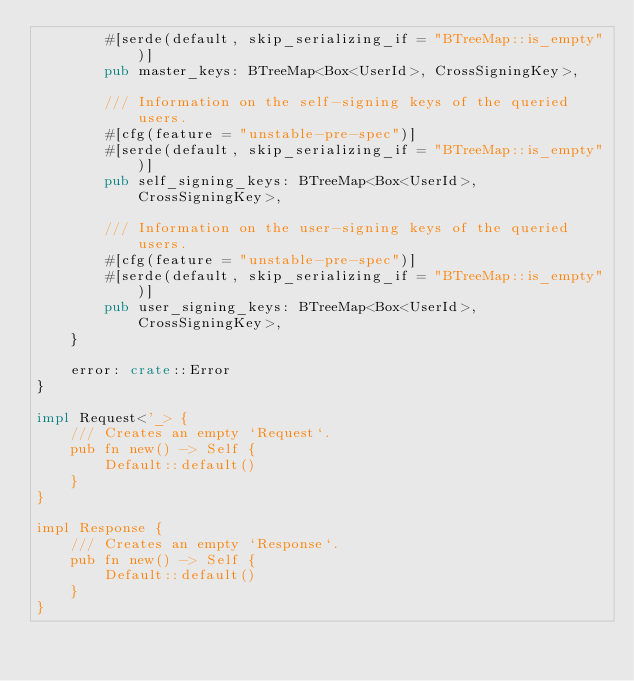<code> <loc_0><loc_0><loc_500><loc_500><_Rust_>        #[serde(default, skip_serializing_if = "BTreeMap::is_empty")]
        pub master_keys: BTreeMap<Box<UserId>, CrossSigningKey>,

        /// Information on the self-signing keys of the queried users.
        #[cfg(feature = "unstable-pre-spec")]
        #[serde(default, skip_serializing_if = "BTreeMap::is_empty")]
        pub self_signing_keys: BTreeMap<Box<UserId>, CrossSigningKey>,

        /// Information on the user-signing keys of the queried users.
        #[cfg(feature = "unstable-pre-spec")]
        #[serde(default, skip_serializing_if = "BTreeMap::is_empty")]
        pub user_signing_keys: BTreeMap<Box<UserId>, CrossSigningKey>,
    }

    error: crate::Error
}

impl Request<'_> {
    /// Creates an empty `Request`.
    pub fn new() -> Self {
        Default::default()
    }
}

impl Response {
    /// Creates an empty `Response`.
    pub fn new() -> Self {
        Default::default()
    }
}
</code> 